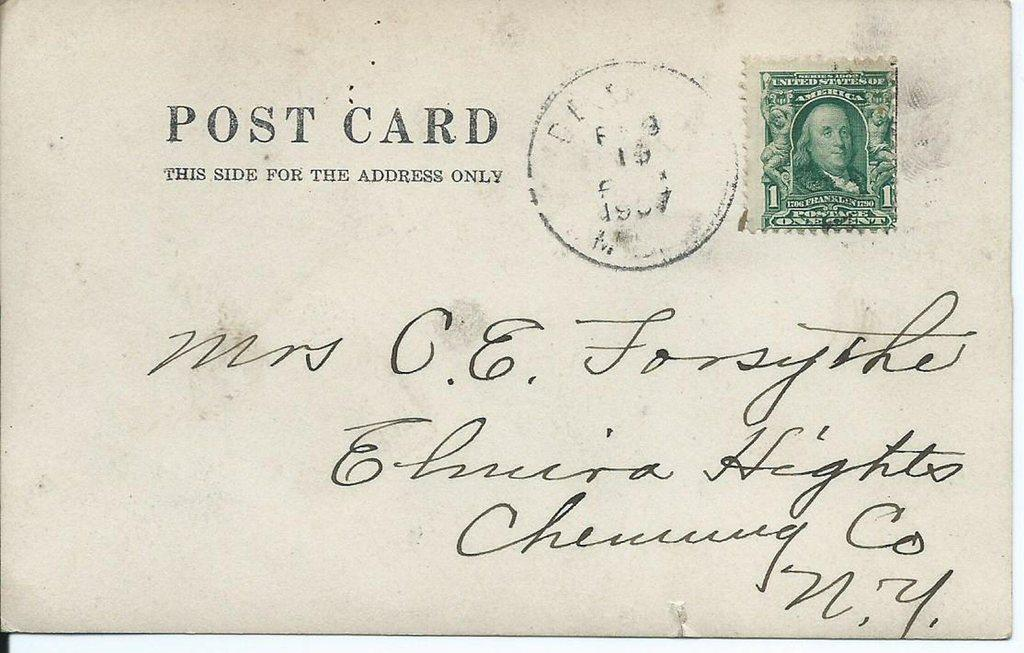What is the main object in the image? There is a letter in the image. Where is the letter located? The letter is placed on a surface. What can be seen on the letter? There is a post stamp on the letter, and it has a logo. What type of content is present on the letter? There is some text and written words on the letter. What type of lunchroom can be seen in the image? There is no lunchroom present in the image; it features a letter with a post stamp, logo, and text. 